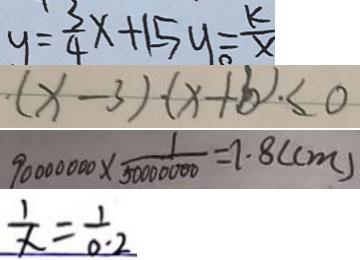Convert formula to latex. <formula><loc_0><loc_0><loc_500><loc_500>y = \frac { 3 } { 4 } x + 1 5 y = \frac { k } { x } 
 ( x - 3 ) \cdot ( x + b ) \cdot \leq 0 
 9 0 0 0 0 0 0 0 \times \frac { 1 } { 5 0 0 0 0 0 0 0 } = 7 . 8 ( c m ) 
 \frac { 1 } { x } = \frac { 1 } { 0 . 2 }</formula> 